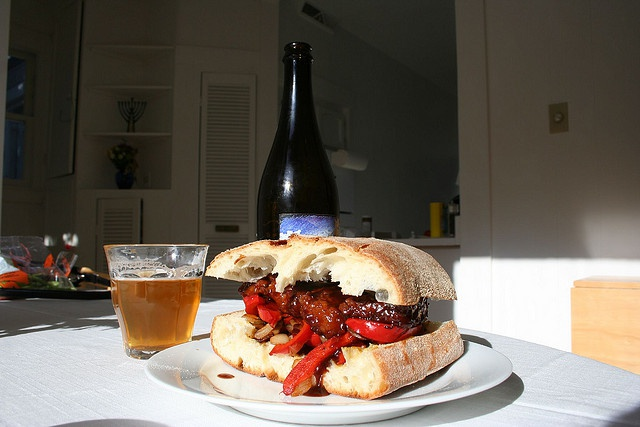Describe the objects in this image and their specific colors. I can see dining table in black, lightgray, gray, and darkgray tones, sandwich in black, beige, tan, and maroon tones, bottle in black, gray, and darkgray tones, cup in black, brown, darkgray, gray, and maroon tones, and wine glass in black, gray, and maroon tones in this image. 